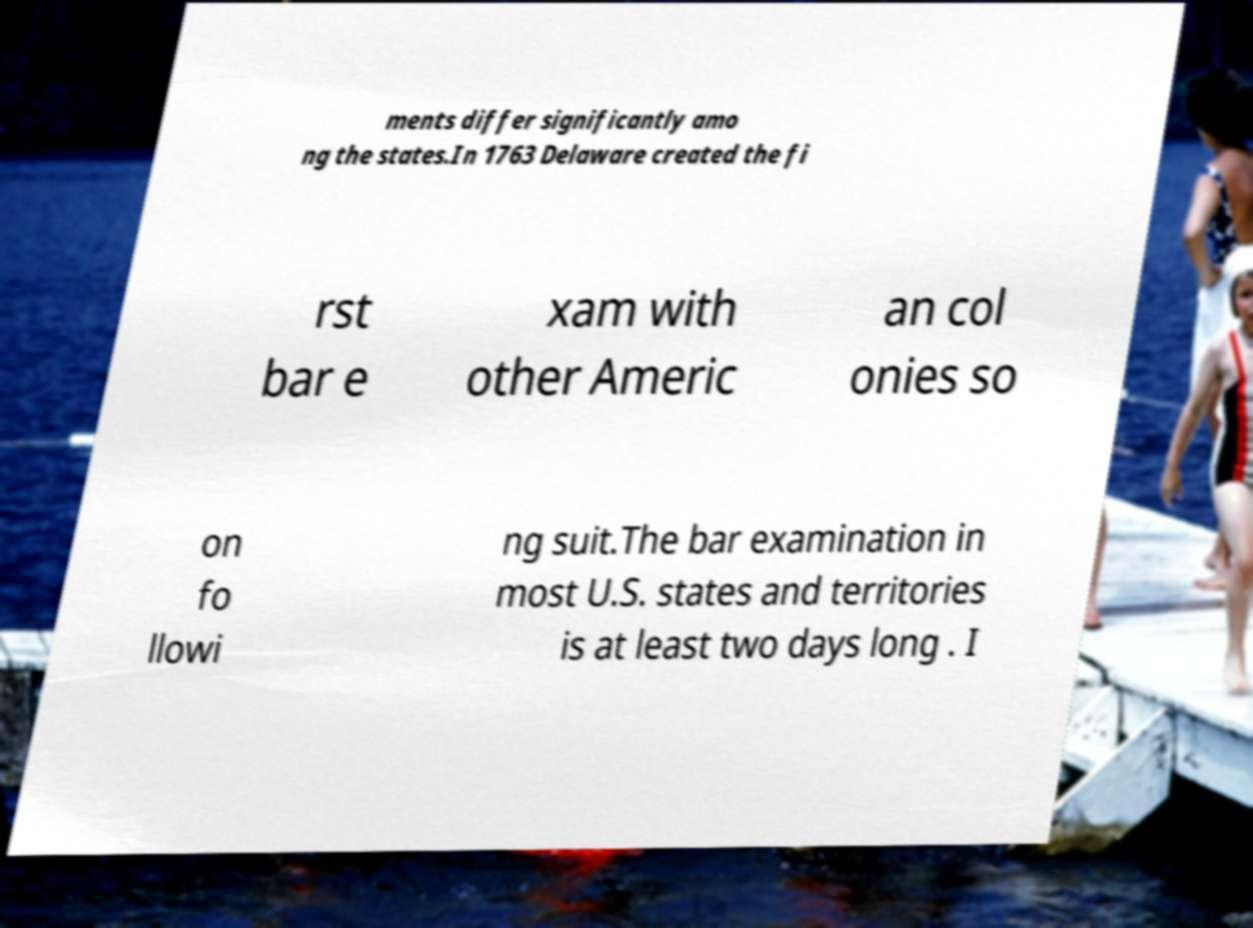What messages or text are displayed in this image? I need them in a readable, typed format. ments differ significantly amo ng the states.In 1763 Delaware created the fi rst bar e xam with other Americ an col onies so on fo llowi ng suit.The bar examination in most U.S. states and territories is at least two days long . I 